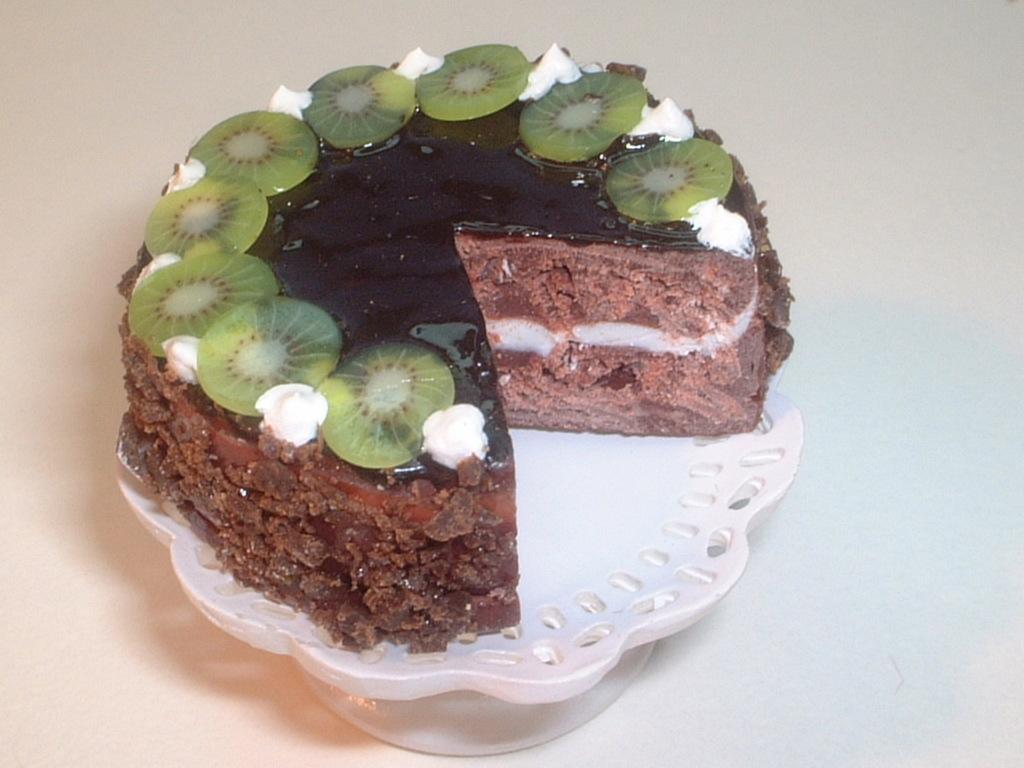In one or two sentences, can you explain what this image depicts? In the center of the image there is a table. On the table, we can see one cake stand. On the cake stand, we can see one cake. On the cake, we can see some cream and some fruit slices. 